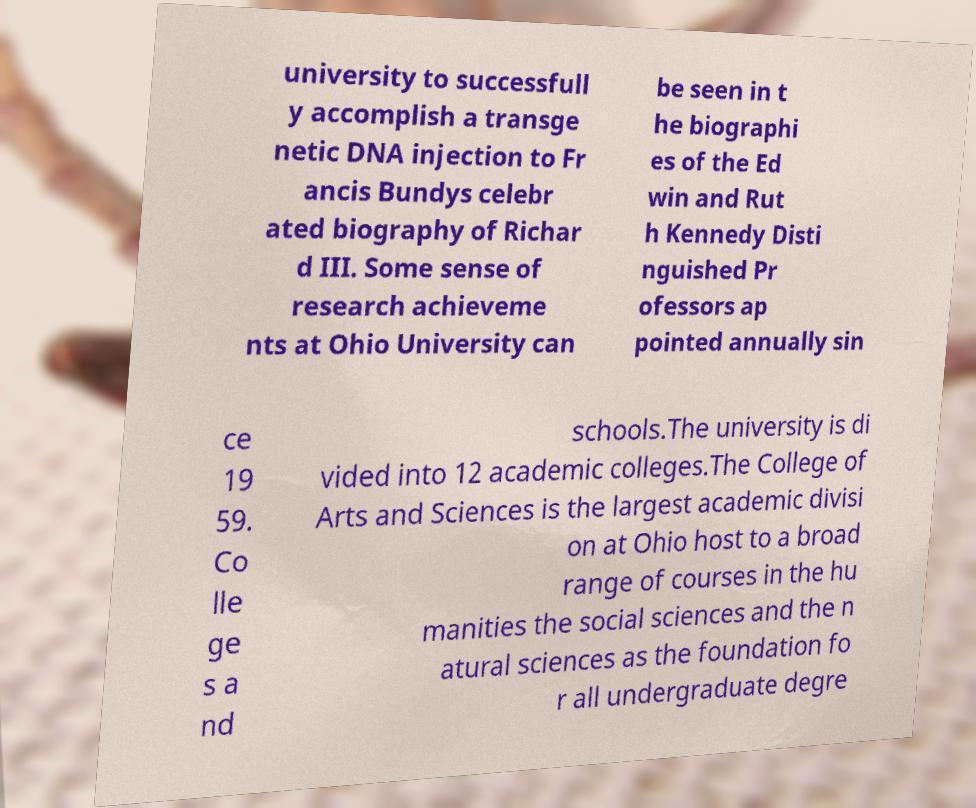Can you accurately transcribe the text from the provided image for me? university to successfull y accomplish a transge netic DNA injection to Fr ancis Bundys celebr ated biography of Richar d III. Some sense of research achieveme nts at Ohio University can be seen in t he biographi es of the Ed win and Rut h Kennedy Disti nguished Pr ofessors ap pointed annually sin ce 19 59. Co lle ge s a nd schools.The university is di vided into 12 academic colleges.The College of Arts and Sciences is the largest academic divisi on at Ohio host to a broad range of courses in the hu manities the social sciences and the n atural sciences as the foundation fo r all undergraduate degre 